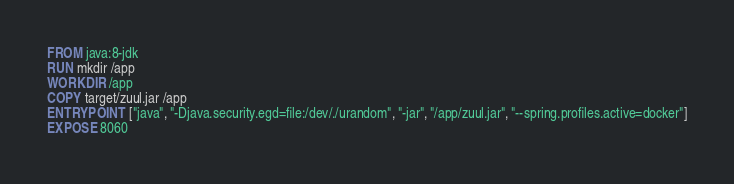<code> <loc_0><loc_0><loc_500><loc_500><_Dockerfile_>FROM java:8-jdk
RUN mkdir /app
WORKDIR /app
COPY target/zuul.jar /app
ENTRYPOINT ["java", "-Djava.security.egd=file:/dev/./urandom", "-jar", "/app/zuul.jar", "--spring.profiles.active=docker"]
EXPOSE 8060</code> 